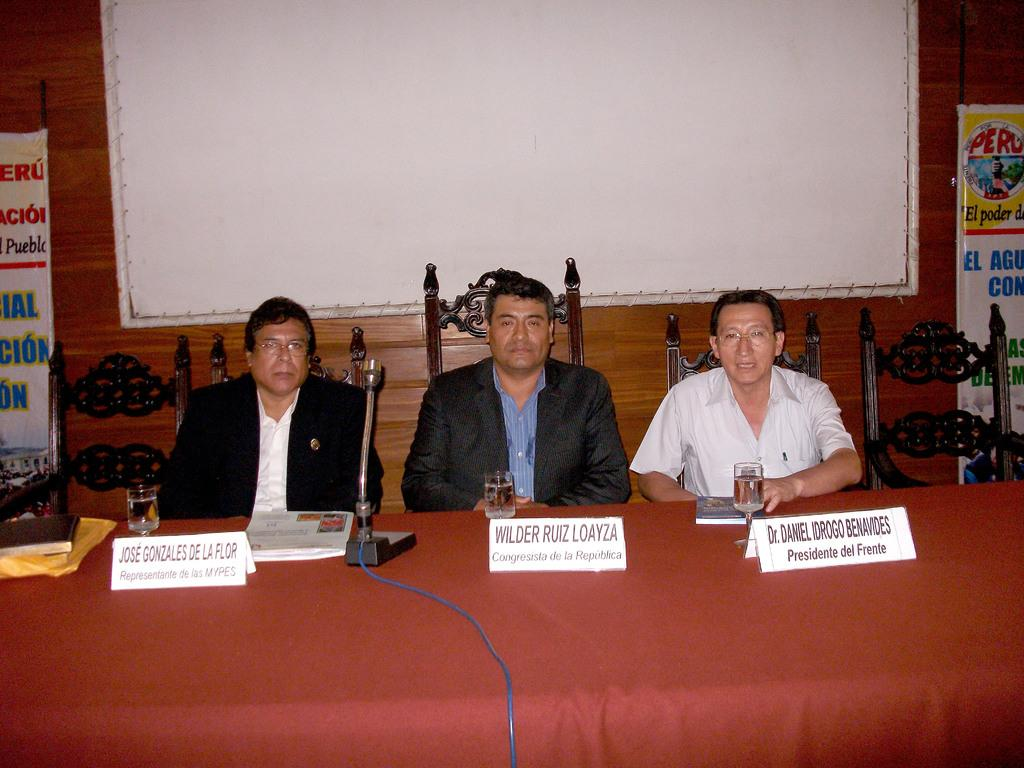Provide a one-sentence caption for the provided image. A representative, a congressman and a president sit at a conference table. 